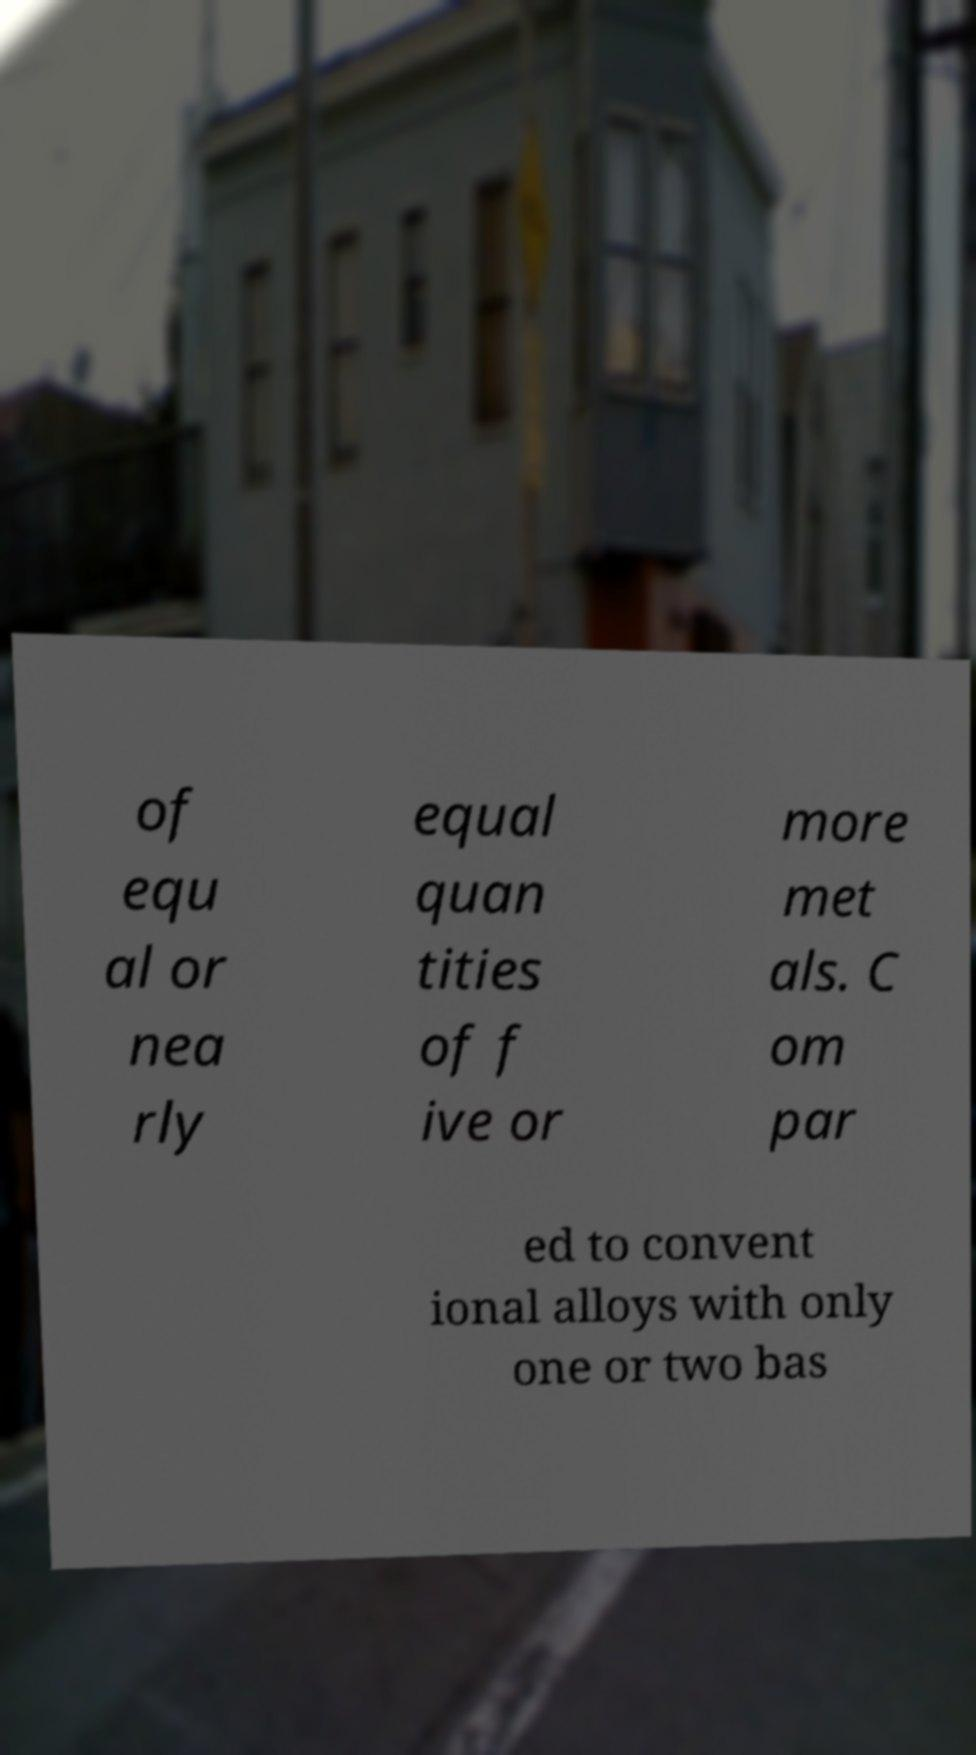What messages or text are displayed in this image? I need them in a readable, typed format. of equ al or nea rly equal quan tities of f ive or more met als. C om par ed to convent ional alloys with only one or two bas 